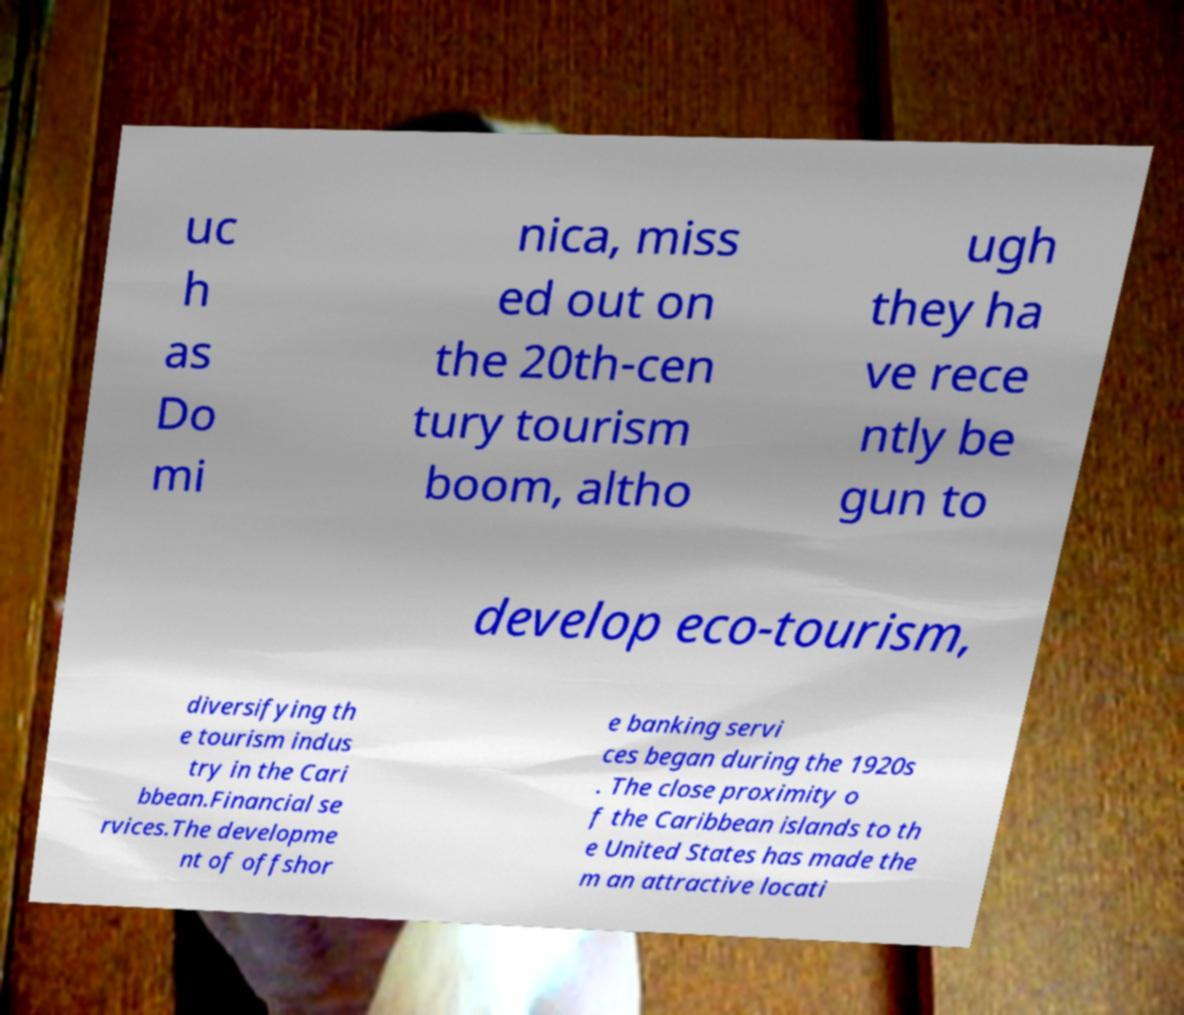There's text embedded in this image that I need extracted. Can you transcribe it verbatim? uc h as Do mi nica, miss ed out on the 20th-cen tury tourism boom, altho ugh they ha ve rece ntly be gun to develop eco-tourism, diversifying th e tourism indus try in the Cari bbean.Financial se rvices.The developme nt of offshor e banking servi ces began during the 1920s . The close proximity o f the Caribbean islands to th e United States has made the m an attractive locati 